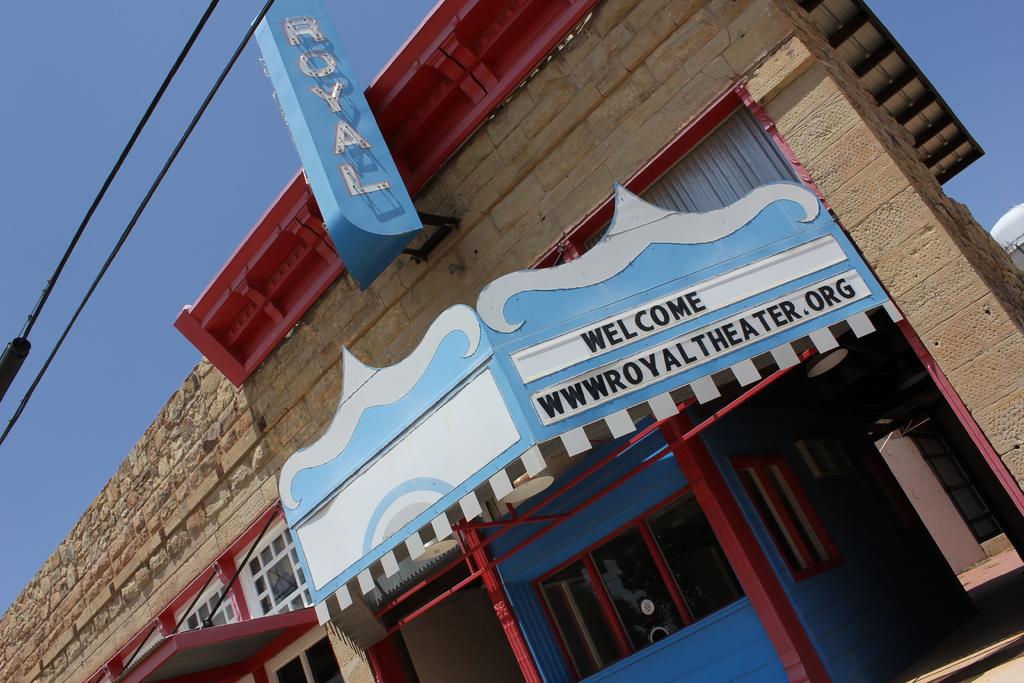What is the name of the theater?
Give a very brief answer. Royal. What is the last letter of the web address?
Offer a very short reply. G. 